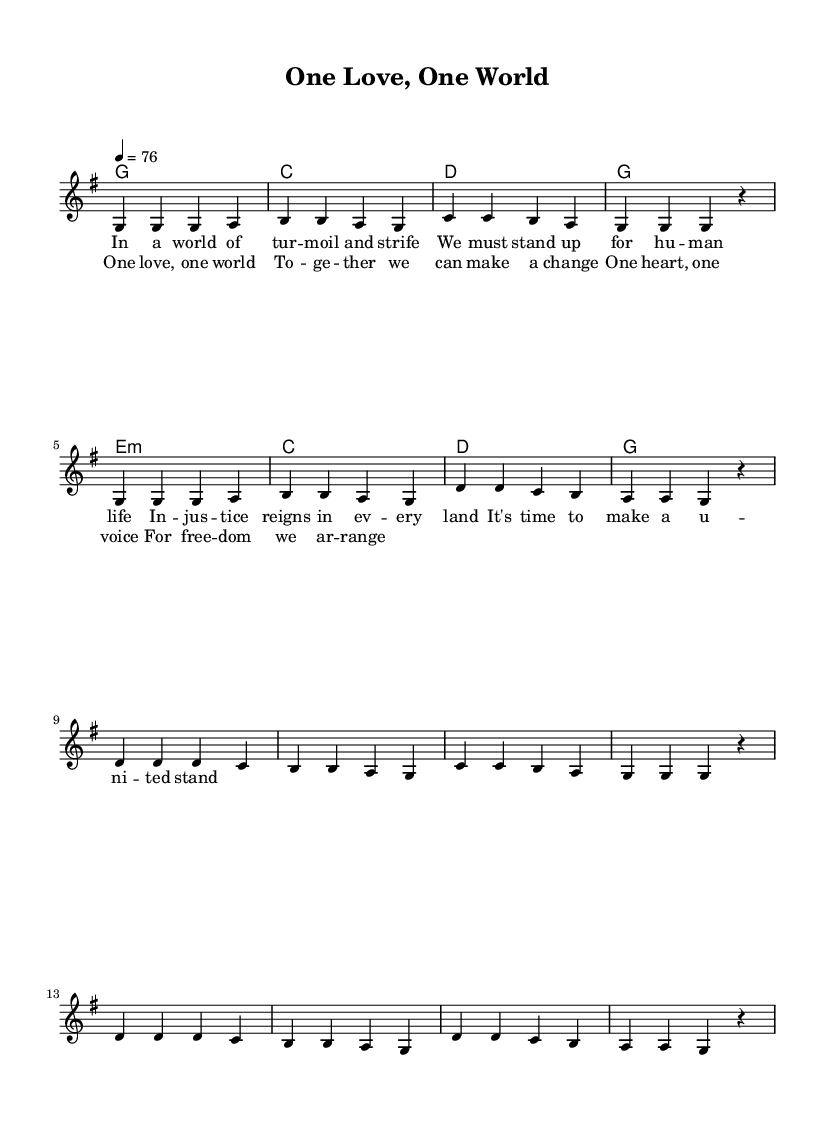What is the key signature of this music? The key signature is G major, which has one sharp (F#). This can be determined by looking at the 'global' section where the command '\key g \major' is specified.
Answer: G major What is the time signature of this music? The time signature is 4/4, which indicates that there are four beats per measure and the quarter note receives one beat. This is noted at the beginning of the score.
Answer: 4/4 What is the tempo marking for this piece? The tempo marking is 76 beats per minute, indicated by the command ‘\tempo 4 = 76’ in the global section. It specifies the speed at which the music should be performed.
Answer: 76 How many verses are in the song? The song contains one verse as evident from the structure indicated in the sheet music; there is a clear distinction between the verse and chorus sections.
Answer: One What themes are reflected in the lyrics of this reggae song? The lyrics reflect themes of social justice, unity, and freedom, which are common in reggae music that addresses global issues. The lyrics encourage standing up for human rights, highlighted in phrases like "make a united stand."
Answer: Social justice and unity What is the overall mood conveyed by the music? The overall mood is uplifting and encouraging, aimed at inspiring listeners to take action for change. This is characteristic of reggae music that promotes hope and positive social messages.
Answer: Uplifting What is the first line of the chorus? The first line of the chorus is "One love, one world," as it is explicitly indicated in the lyrics section following the melody.
Answer: One love, one world 